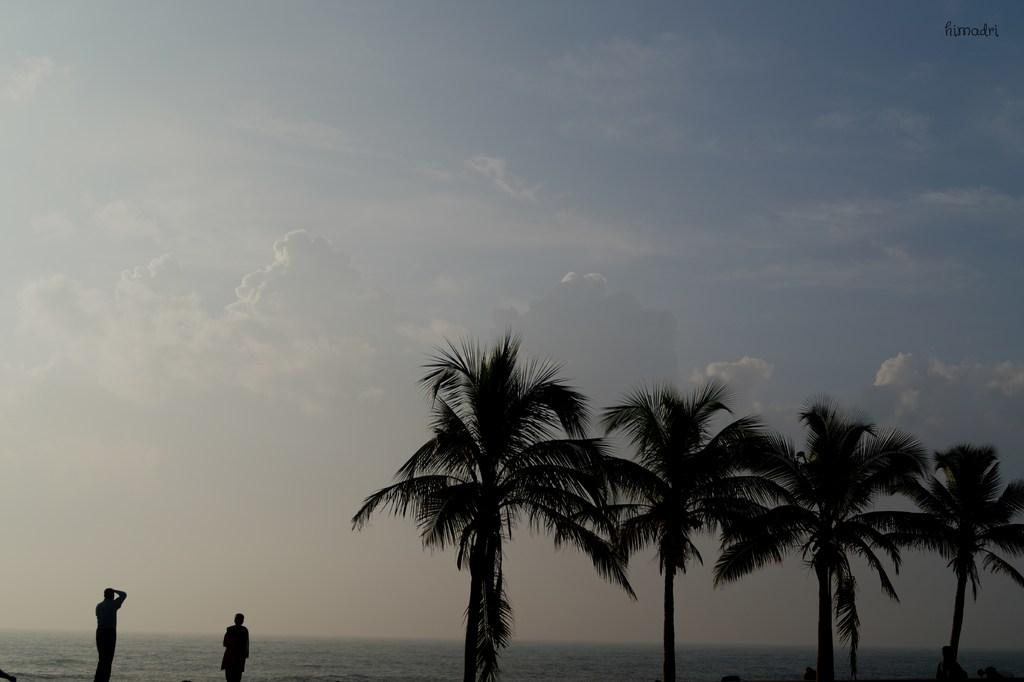How many people are standing in the image? There are two people standing in the image. What can be seen in the background besides the sky? Trees and water are visible in the background. What is the condition of the sky in the image? The sky is visible with clouds in the image. What type of brush can be seen in the hands of one of the people in the image? There is no brush present in the image; both people are standing without any visible objects in their hands. 